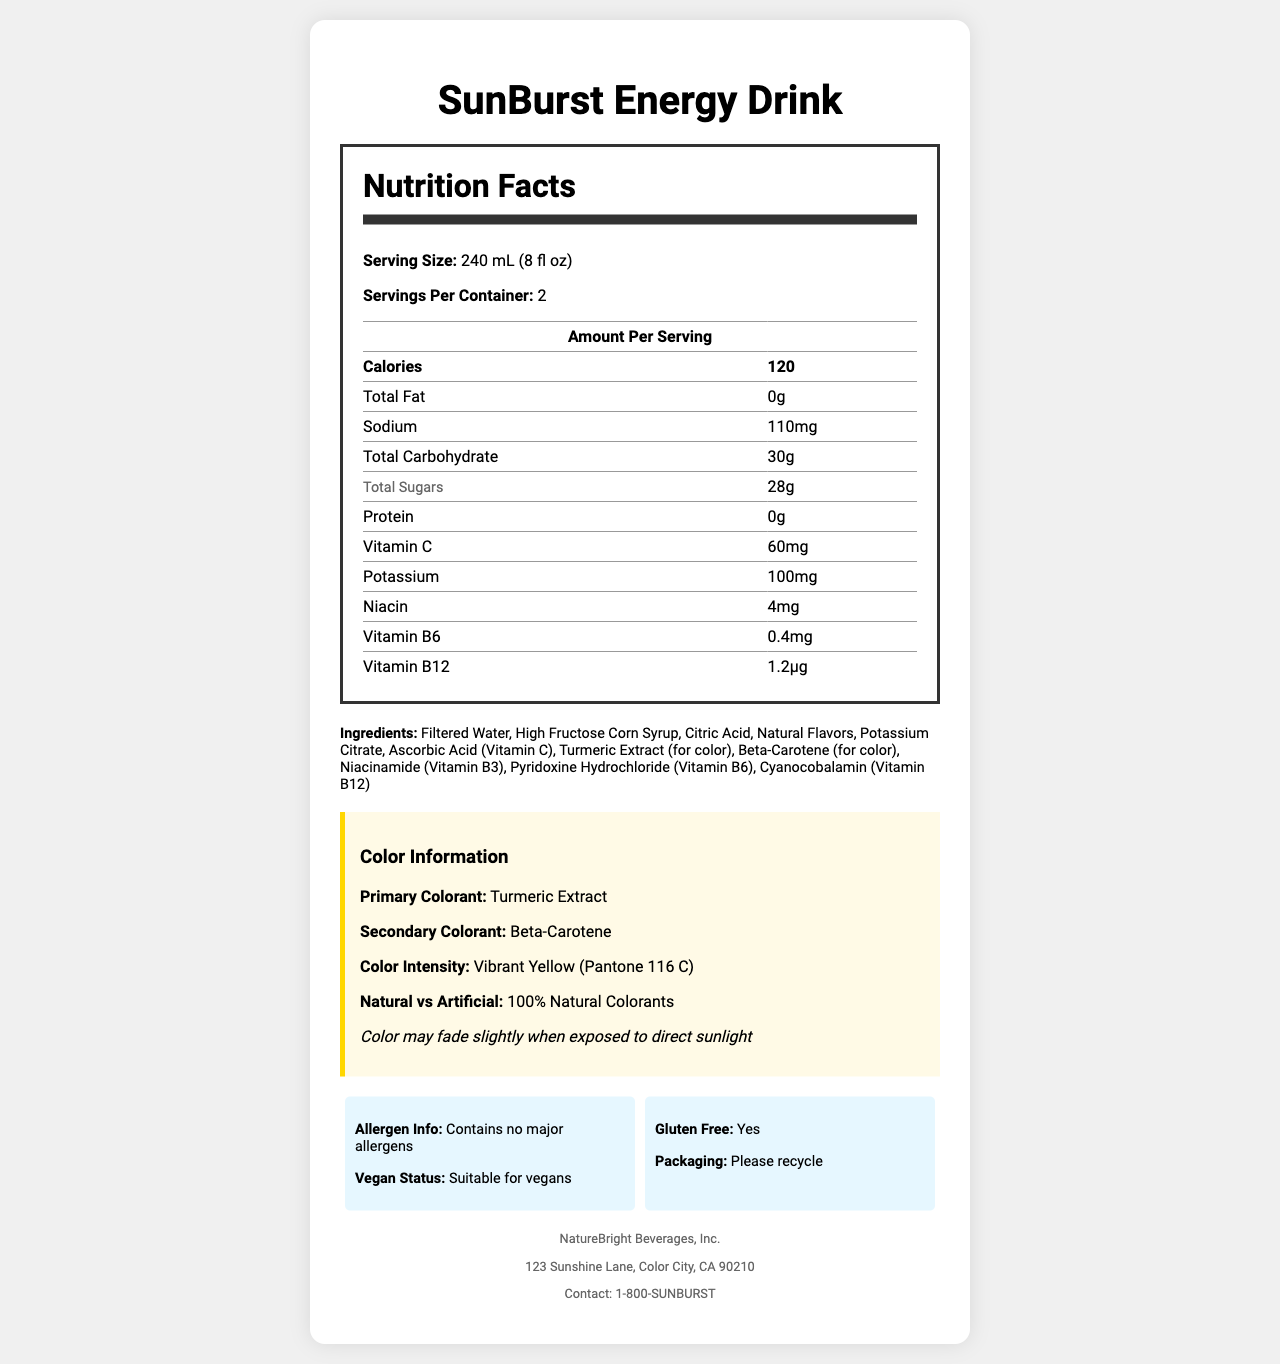what is the serving size for SunBurst Energy Drink? The serving size is clearly stated in the "Nutrition Facts" section of the document.
Answer: 240 mL (8 fl oz) How many servings are there per container? The document specifies that there are 2 servings per container.
Answer: 2 What are the primary and secondary colorants used in SunBurst Energy Drink? This information is highlighted under the "Color Information" section.
Answer: Primary: Turmeric Extract, Secondary: Beta-Carotene What is the overall calorie count per serving? The document lists the calorie count in the "Nutrition Facts" table.
Answer: 120 calories Is this drink suitable for vegans? The vegan status is provided in the "Additional Information" section.
Answer: Yes Which vitamin is present in the largest amount? A. Vitamin C B. Vitamin B6 C. Niacin D. Vitamin B12 The document states that Vitamin C is present in the highest quantity, 60mg.
Answer: A. Vitamin C What percentage of Turmeric Extract is used in the color formulation? A. 0.01% B. 0.05% C. 0.02% D. 0.10% The ink technician notes provide the concentration of Turmeric Extract.
Answer: B. 0.05% Are there any major allergens in SunBurst Energy Drink? The allergen statement in the "Additional Information" section confirms that there are no major allergens.
Answer: No Is the color of the drink likely to change when exposed to direct sunlight? There is a note under the "Color Information" section stating that the color may fade slightly when exposed to direct sunlight.
Answer: Yes What is the main idea of the document? The document organizes a comprehensive overview of the SunBurst Energy Drink, covering its nutritional facts, ingredients, colorant properties, and additional product-related information.
Answer: The document provides detailed nutritional information, ingredients, and colorant details for SunBurst Energy Drink. It highlights that the drink is a vibrant yellow sports drink, using 100% natural colorants, and includes allergen information, vegan status, and packaging recyclability. What is the company's contact number? The manufacturer's details at the bottom of the document list the contact number.
Answer: 1-800-SUNBURST How many grams of sugar are there per serving? The "Nutrition Facts" table specifies the amount of total sugars per serving.
Answer: 28g Can the exact pH stability range be determined from the document? The ink technician notes state that the drink’s color is stable between pH 3.5-4.5.
Answer: Yes What is the exact shade of yellow according to Pantone? The color intensity section lists the specific Pantone color code.
Answer: Pantone 116 C What is the country's packaging recyclability status? The document states "Please recycle" but does not provide specific country-based packaging recyclability details.
Answer: Not enough information 